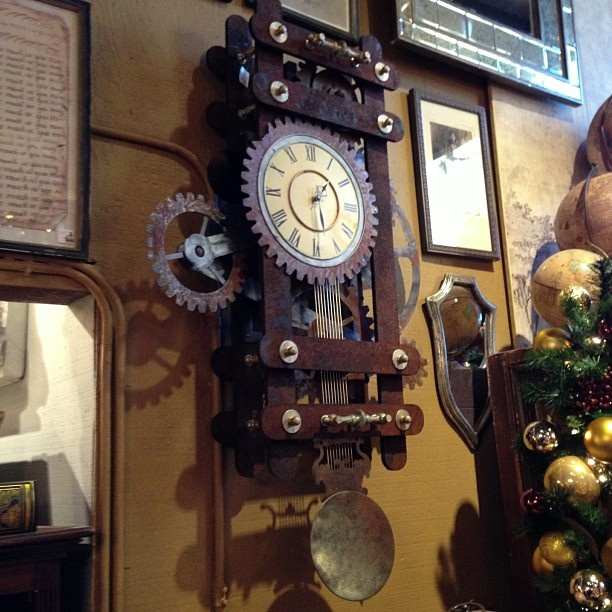Describe the objects in this image and their specific colors. I can see a clock in gray, beige, and darkgray tones in this image. 